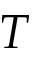Convert formula to latex. <formula><loc_0><loc_0><loc_500><loc_500>T</formula> 